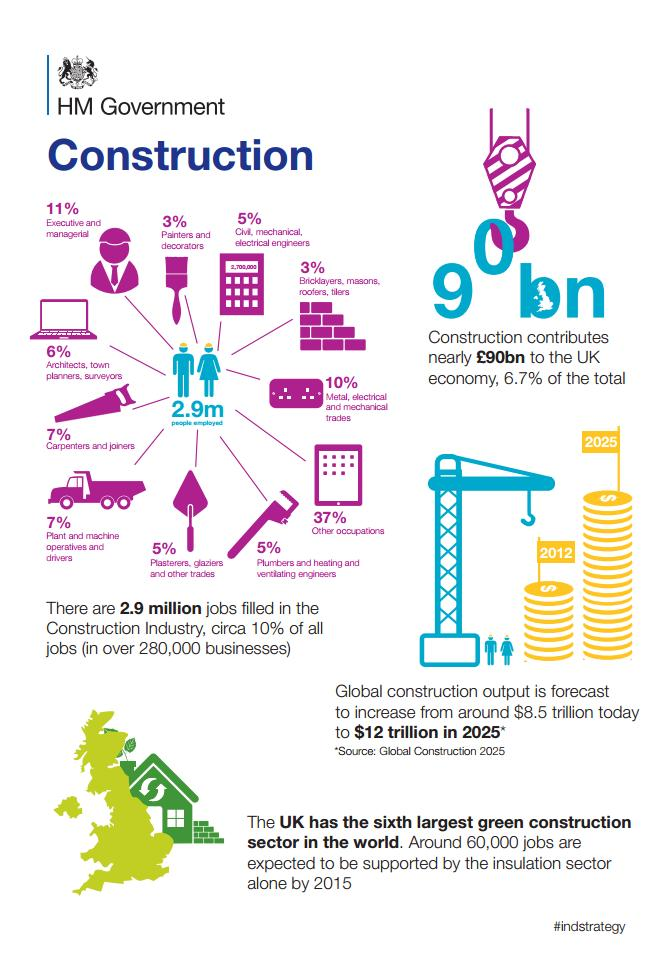Outline some significant characteristics in this image. According to recent data, approximately 7% of the workforce in the construction industry is composed of carpenters, joiners, operators, and drivers. In the construction industry, approximately 17% of the workforce is comprised of managerial staff, architects, planners, and surveyors. The percentage of painters and decorators in the construction industry is 11%, 3%, or 5%. It is 3%. 